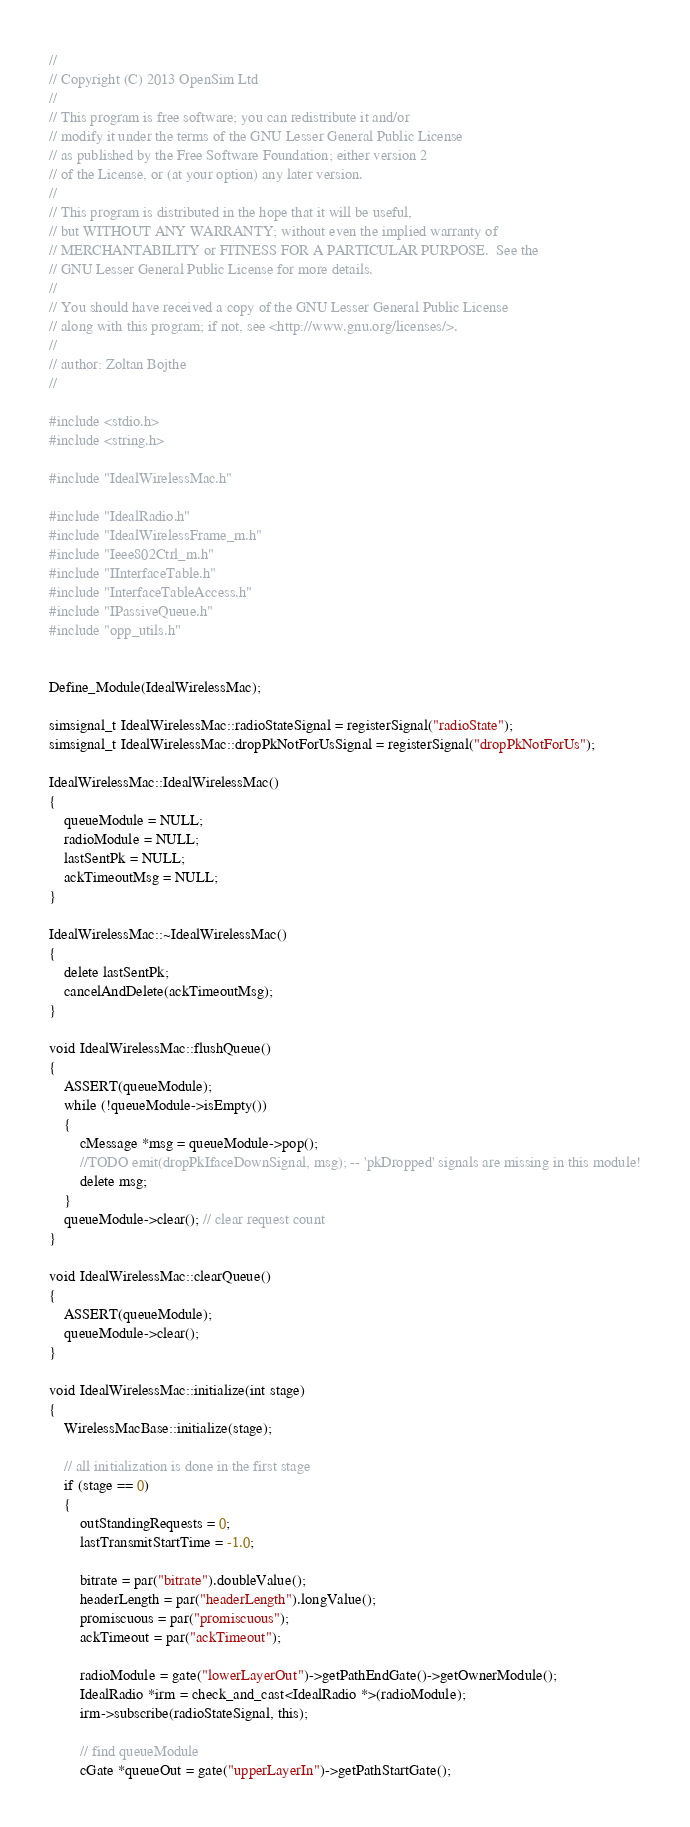<code> <loc_0><loc_0><loc_500><loc_500><_C++_>//
// Copyright (C) 2013 OpenSim Ltd
//
// This program is free software; you can redistribute it and/or
// modify it under the terms of the GNU Lesser General Public License
// as published by the Free Software Foundation; either version 2
// of the License, or (at your option) any later version.
//
// This program is distributed in the hope that it will be useful,
// but WITHOUT ANY WARRANTY; without even the implied warranty of
// MERCHANTABILITY or FITNESS FOR A PARTICULAR PURPOSE.  See the
// GNU Lesser General Public License for more details.
//
// You should have received a copy of the GNU Lesser General Public License
// along with this program; if not, see <http://www.gnu.org/licenses/>.
//
// author: Zoltan Bojthe
//

#include <stdio.h>
#include <string.h>

#include "IdealWirelessMac.h"

#include "IdealRadio.h"
#include "IdealWirelessFrame_m.h"
#include "Ieee802Ctrl_m.h"
#include "IInterfaceTable.h"
#include "InterfaceTableAccess.h"
#include "IPassiveQueue.h"
#include "opp_utils.h"


Define_Module(IdealWirelessMac);

simsignal_t IdealWirelessMac::radioStateSignal = registerSignal("radioState");
simsignal_t IdealWirelessMac::dropPkNotForUsSignal = registerSignal("dropPkNotForUs");

IdealWirelessMac::IdealWirelessMac()
{
    queueModule = NULL;
    radioModule = NULL;
    lastSentPk = NULL;
    ackTimeoutMsg = NULL;
}

IdealWirelessMac::~IdealWirelessMac()
{
    delete lastSentPk;
    cancelAndDelete(ackTimeoutMsg);
}

void IdealWirelessMac::flushQueue()
{
    ASSERT(queueModule);
    while (!queueModule->isEmpty())
    {
        cMessage *msg = queueModule->pop();
        //TODO emit(dropPkIfaceDownSignal, msg); -- 'pkDropped' signals are missing in this module!
        delete msg;
    }
    queueModule->clear(); // clear request count
}

void IdealWirelessMac::clearQueue()
{
    ASSERT(queueModule);
    queueModule->clear();
}

void IdealWirelessMac::initialize(int stage)
{
    WirelessMacBase::initialize(stage);

    // all initialization is done in the first stage
    if (stage == 0)
    {
        outStandingRequests = 0;
        lastTransmitStartTime = -1.0;

        bitrate = par("bitrate").doubleValue();
        headerLength = par("headerLength").longValue();
        promiscuous = par("promiscuous");
        ackTimeout = par("ackTimeout");

        radioModule = gate("lowerLayerOut")->getPathEndGate()->getOwnerModule();
        IdealRadio *irm = check_and_cast<IdealRadio *>(radioModule);
        irm->subscribe(radioStateSignal, this);

        // find queueModule
        cGate *queueOut = gate("upperLayerIn")->getPathStartGate();</code> 